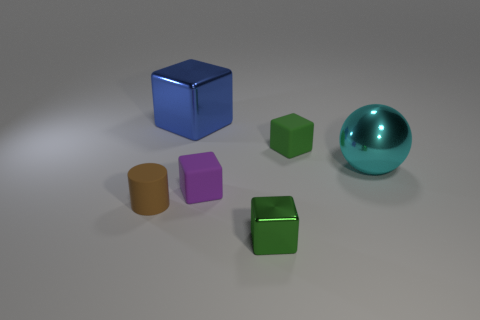Add 2 large purple metal cylinders. How many objects exist? 8 Subtract all blocks. How many objects are left? 2 Add 4 green cubes. How many green cubes exist? 6 Subtract 0 purple balls. How many objects are left? 6 Subtract all tiny purple rubber objects. Subtract all cylinders. How many objects are left? 4 Add 2 matte cylinders. How many matte cylinders are left? 3 